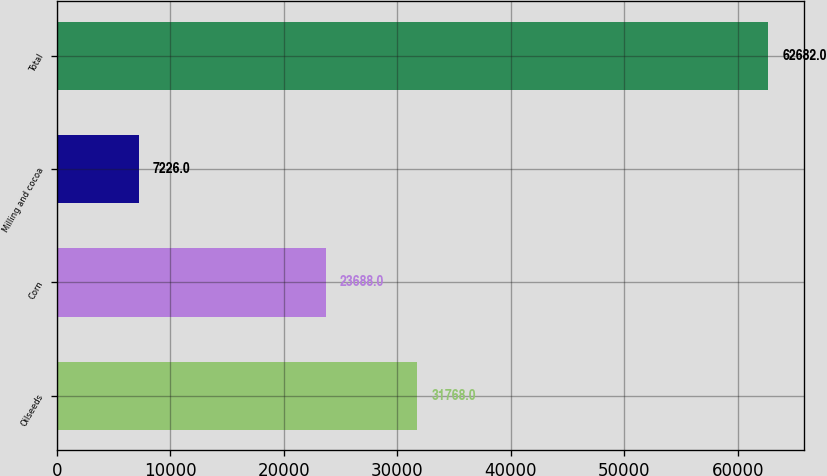Convert chart. <chart><loc_0><loc_0><loc_500><loc_500><bar_chart><fcel>Oilseeds<fcel>Corn<fcel>Milling and cocoa<fcel>Total<nl><fcel>31768<fcel>23688<fcel>7226<fcel>62682<nl></chart> 